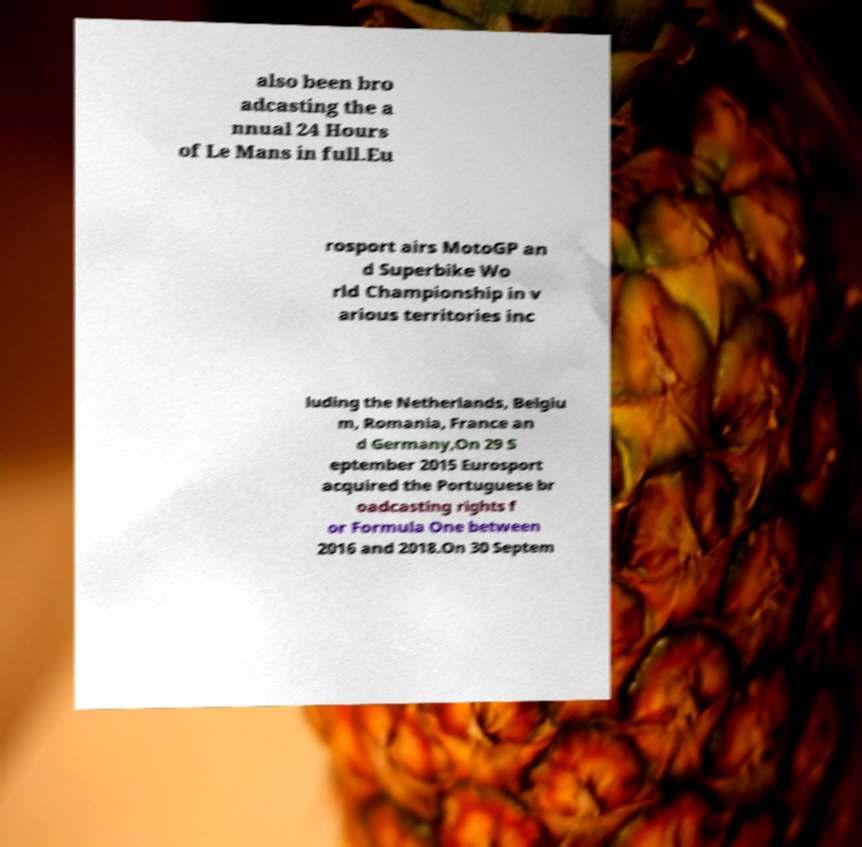Could you extract and type out the text from this image? also been bro adcasting the a nnual 24 Hours of Le Mans in full.Eu rosport airs MotoGP an d Superbike Wo rld Championship in v arious territories inc luding the Netherlands, Belgiu m, Romania, France an d Germany,On 29 S eptember 2015 Eurosport acquired the Portuguese br oadcasting rights f or Formula One between 2016 and 2018.On 30 Septem 